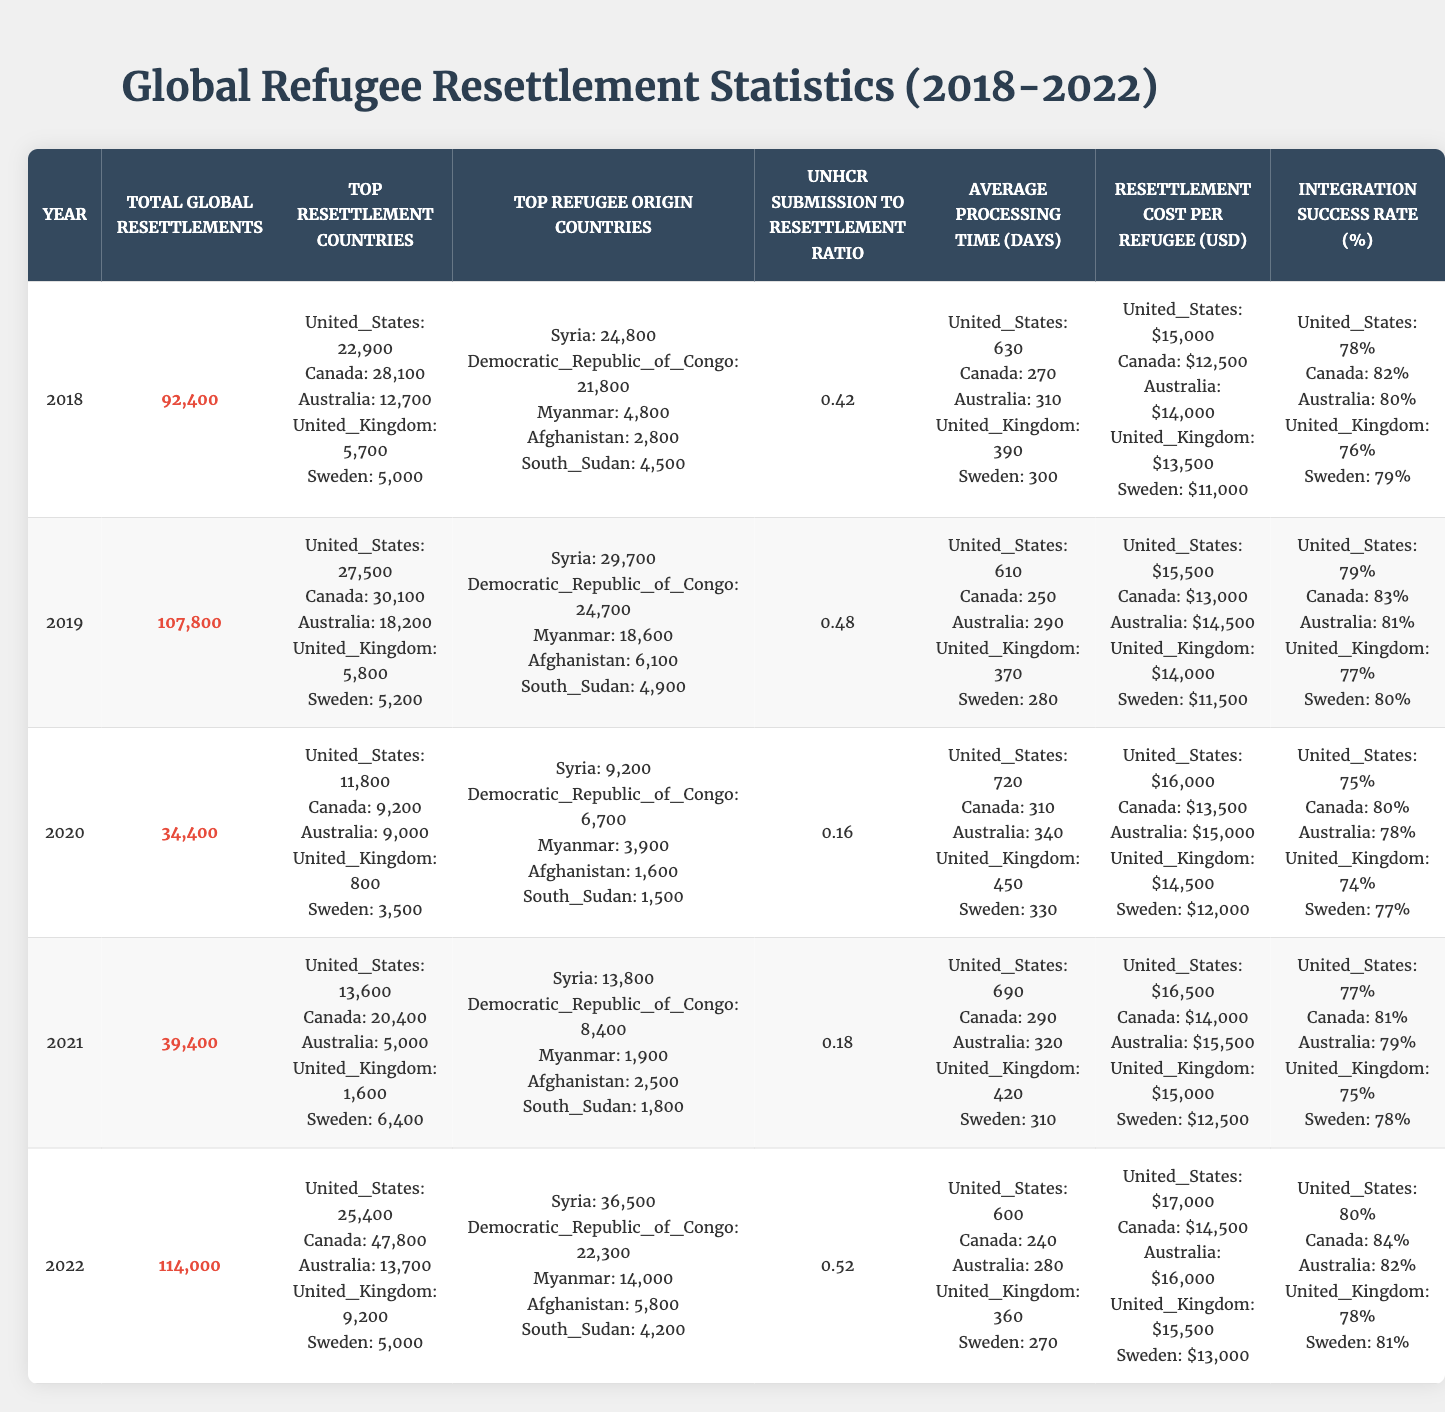What was the total number of global resettlements in 2020? Referring to the "Total Global Resettlements" column for the year 2020, the value is 34,400.
Answer: 34,400 Which country had the highest number of resettlements in 2022? Looking at the "Top Resettlement Countries" for the year 2022, Canada had 47,800 resettlements, which is the highest among the listed countries.
Answer: Canada What was the average processing time for resettlements in the United States in 2019? The "Average Processing Time (Days)" for the United States in 2019 is listed as 610 days.
Answer: 610 Did the integration success rate of the United Kingdom increase from 2018 to 2022? Comparing the integration success rates for the United Kingdom from 2018 (76%) to 2022 (78%), we see an increase of 2 percentage points.
Answer: Yes What is the total number of resettlements for Australia over the five years? Summing the resettlements for Australia from 2018 to 2022 gives (12,700 + 18,200 + 9,000 + 5,000 + 13,700) = 58,600.
Answer: 58,600 What was the UNHCR submission to resettlement ratio in 2021? The ratio for 2021 is listed in the table as 0.18.
Answer: 0.18 Which origin country had the highest refugee resettlement count in 2022? Reviewing the "Top Refugee Origin Countries" for 2022, Syria had the highest at 36,500.
Answer: Syria How much did the cost per resettled refugee increase for the United States from 2018 to 2022? The cost per refugee in the United States increased from $15,000 in 2018 to $17,000 in 2022, representing an increase of $2,000.
Answer: $2,000 What was the average integration success rate across all countries in 2020? For 2020, the integration success rates are 75% (US), 80% (Canada), 78% (Australia), 74% (UK), and 77% (Sweden). The average is (75+80+78+74+77)/5 = 76.8%.
Answer: 76.8% In which year did the total global resettlements see the highest number? By comparing the "Total Global Resettlements" for each year, 2022 had the highest with 114,000 resettlements.
Answer: 2022 What is the difference in the average processing time (days) for Canada between 2018 and 2022? In 2018, the processing time for Canada was 270 days, and in 2022 it was 240 days. The difference is 270 - 240 = 30 days.
Answer: 30 days Did Sweden have a consistent increase in resettlement numbers from 2018 to 2022? By examining the numbers for Sweden (5,000, 5,200, 3,500, 6,400, 5,000), there is no consistent increase because it fluctuated.
Answer: No 